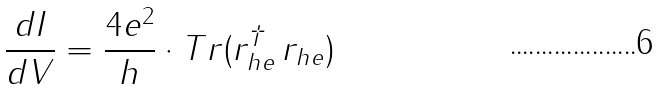<formula> <loc_0><loc_0><loc_500><loc_500>\frac { d I } { d V } = \frac { 4 e ^ { 2 } } { h } \cdot T r ( r _ { h e } ^ { \dagger } \, r _ { h e } )</formula> 